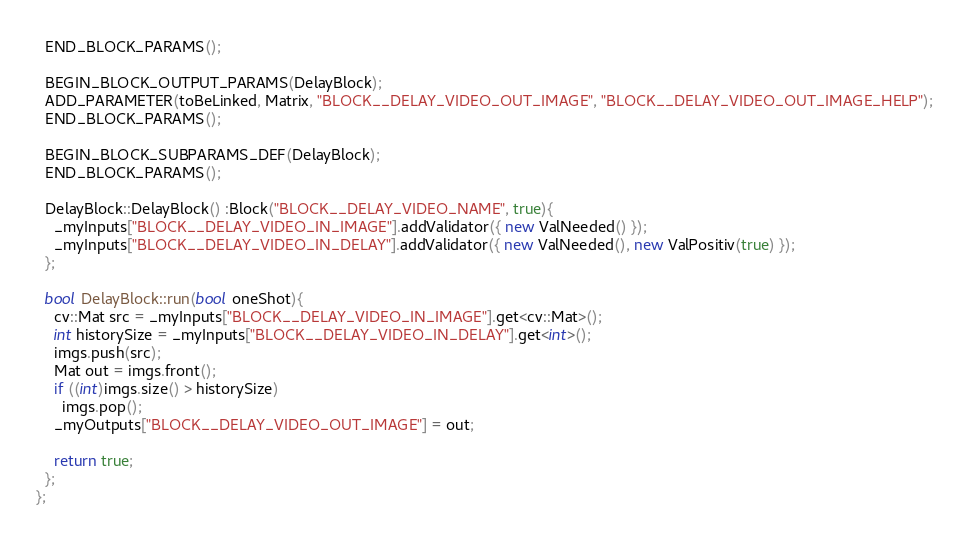<code> <loc_0><loc_0><loc_500><loc_500><_C++_>  END_BLOCK_PARAMS();

  BEGIN_BLOCK_OUTPUT_PARAMS(DelayBlock);
  ADD_PARAMETER(toBeLinked, Matrix, "BLOCK__DELAY_VIDEO_OUT_IMAGE", "BLOCK__DELAY_VIDEO_OUT_IMAGE_HELP");
  END_BLOCK_PARAMS();

  BEGIN_BLOCK_SUBPARAMS_DEF(DelayBlock);
  END_BLOCK_PARAMS();

  DelayBlock::DelayBlock() :Block("BLOCK__DELAY_VIDEO_NAME", true){
    _myInputs["BLOCK__DELAY_VIDEO_IN_IMAGE"].addValidator({ new ValNeeded() });
    _myInputs["BLOCK__DELAY_VIDEO_IN_DELAY"].addValidator({ new ValNeeded(), new ValPositiv(true) });
  };
  
  bool DelayBlock::run(bool oneShot){
    cv::Mat src = _myInputs["BLOCK__DELAY_VIDEO_IN_IMAGE"].get<cv::Mat>();
    int historySize = _myInputs["BLOCK__DELAY_VIDEO_IN_DELAY"].get<int>();
    imgs.push(src);
    Mat out = imgs.front();
    if ((int)imgs.size() > historySize)
      imgs.pop();
    _myOutputs["BLOCK__DELAY_VIDEO_OUT_IMAGE"] = out;

    return true;
  };
};</code> 